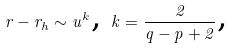Convert formula to latex. <formula><loc_0><loc_0><loc_500><loc_500>r - r _ { h } \sim u ^ { k } \text {, } k = \frac { 2 } { q - p + 2 } \text {, }</formula> 